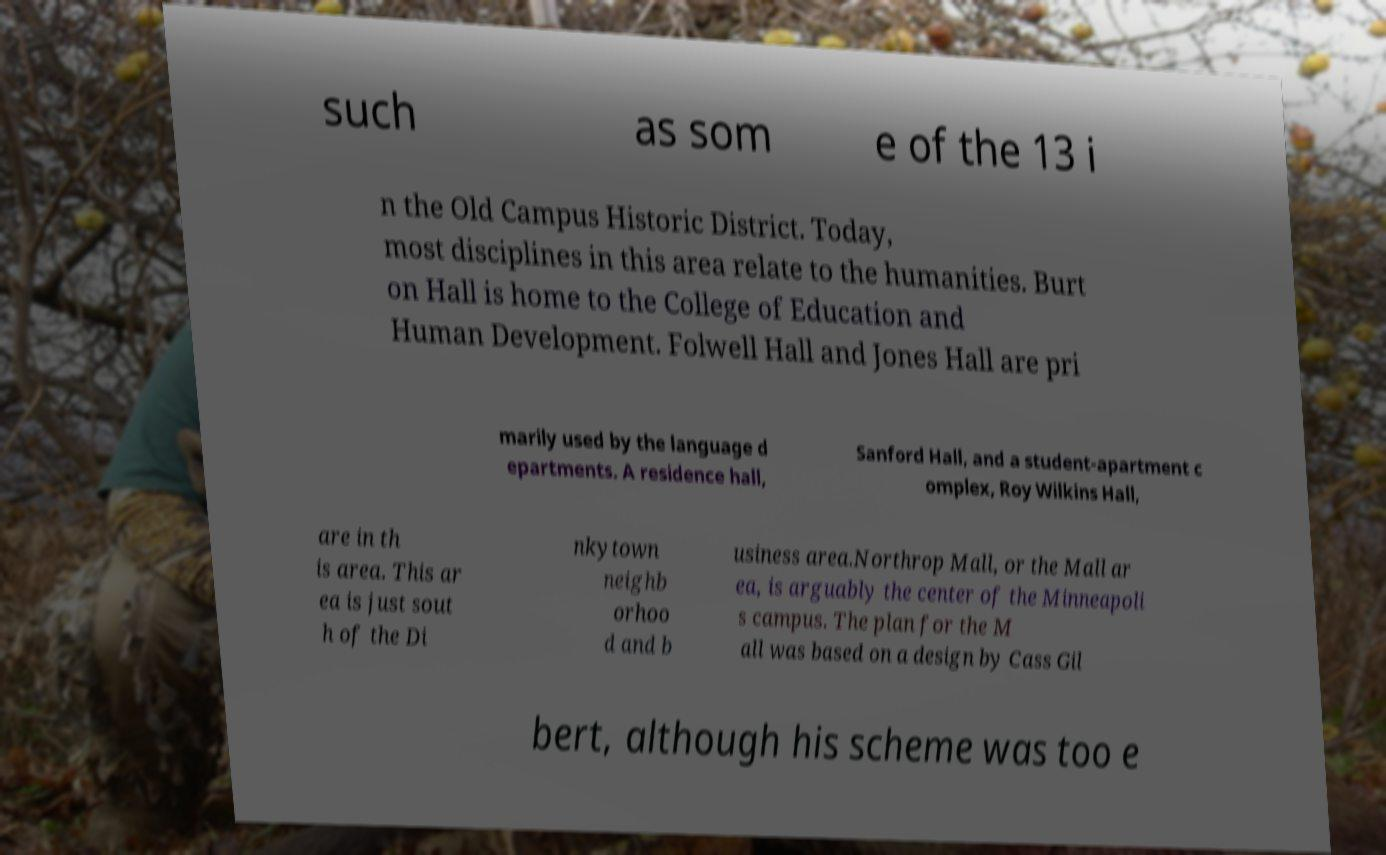Could you assist in decoding the text presented in this image and type it out clearly? such as som e of the 13 i n the Old Campus Historic District. Today, most disciplines in this area relate to the humanities. Burt on Hall is home to the College of Education and Human Development. Folwell Hall and Jones Hall are pri marily used by the language d epartments. A residence hall, Sanford Hall, and a student-apartment c omplex, Roy Wilkins Hall, are in th is area. This ar ea is just sout h of the Di nkytown neighb orhoo d and b usiness area.Northrop Mall, or the Mall ar ea, is arguably the center of the Minneapoli s campus. The plan for the M all was based on a design by Cass Gil bert, although his scheme was too e 